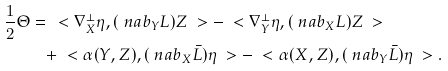<formula> <loc_0><loc_0><loc_500><loc_500>\frac { 1 } { 2 } \Theta = & \, \ < \nabla ^ { \perp } _ { X } \eta , ( \ n a b _ { Y } L ) Z \ > - \ < \nabla ^ { \perp } _ { Y } \eta , ( \ n a b _ { X } L ) Z \ > \\ & + \ < \alpha ( Y , Z ) , ( \ n a b _ { X } \bar { L } ) \eta \ > - \ < \alpha ( X , Z ) , ( \ n a b _ { Y } \bar { L } ) \eta \ > .</formula> 